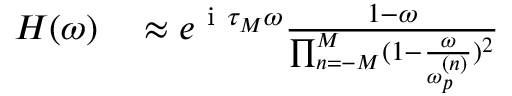<formula> <loc_0><loc_0><loc_500><loc_500>\begin{array} { r } { \begin{array} { r l } { H ( \omega ) } & \approx e ^ { i \tau _ { M } \omega } \frac { 1 - \omega } { \prod _ { n = - M } ^ { M } ( 1 - \frac { \omega } { \omega _ { p } ^ { ( n ) } } ) ^ { 2 } } } \end{array} } \end{array}</formula> 